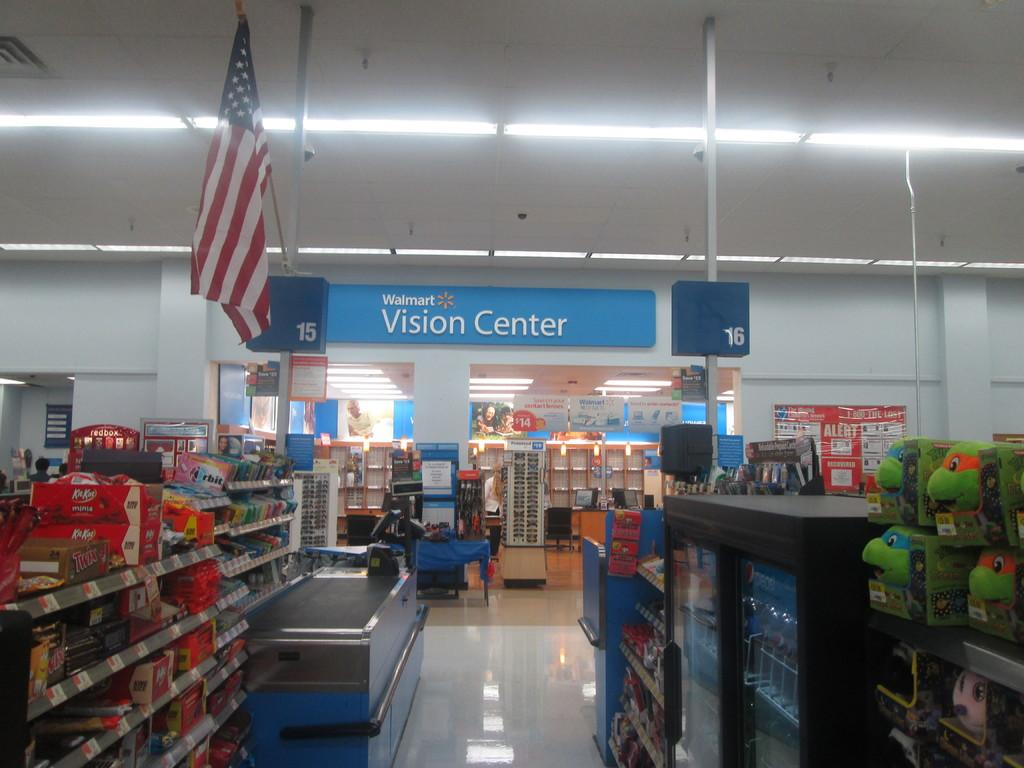Provide a one-sentence caption for the provided image. Walmart shopping center that includes a vision center. 